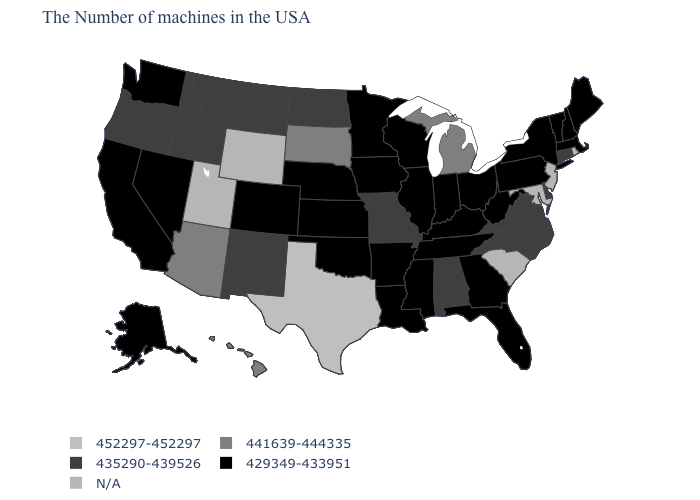What is the value of Georgia?
Concise answer only. 429349-433951. Which states have the highest value in the USA?
Short answer required. Texas. Which states have the lowest value in the USA?
Give a very brief answer. Maine, Massachusetts, New Hampshire, Vermont, New York, Pennsylvania, West Virginia, Ohio, Florida, Georgia, Kentucky, Indiana, Tennessee, Wisconsin, Illinois, Mississippi, Louisiana, Arkansas, Minnesota, Iowa, Kansas, Nebraska, Oklahoma, Colorado, Nevada, California, Washington, Alaska. Which states have the lowest value in the MidWest?
Give a very brief answer. Ohio, Indiana, Wisconsin, Illinois, Minnesota, Iowa, Kansas, Nebraska. What is the value of Arizona?
Quick response, please. 441639-444335. What is the lowest value in the USA?
Keep it brief. 429349-433951. Name the states that have a value in the range 441639-444335?
Write a very short answer. Michigan, South Dakota, Arizona, Hawaii. Is the legend a continuous bar?
Concise answer only. No. Name the states that have a value in the range 429349-433951?
Concise answer only. Maine, Massachusetts, New Hampshire, Vermont, New York, Pennsylvania, West Virginia, Ohio, Florida, Georgia, Kentucky, Indiana, Tennessee, Wisconsin, Illinois, Mississippi, Louisiana, Arkansas, Minnesota, Iowa, Kansas, Nebraska, Oklahoma, Colorado, Nevada, California, Washington, Alaska. Among the states that border Oregon , does Nevada have the highest value?
Write a very short answer. No. Name the states that have a value in the range 429349-433951?
Write a very short answer. Maine, Massachusetts, New Hampshire, Vermont, New York, Pennsylvania, West Virginia, Ohio, Florida, Georgia, Kentucky, Indiana, Tennessee, Wisconsin, Illinois, Mississippi, Louisiana, Arkansas, Minnesota, Iowa, Kansas, Nebraska, Oklahoma, Colorado, Nevada, California, Washington, Alaska. What is the value of Oregon?
Write a very short answer. 435290-439526. What is the value of West Virginia?
Quick response, please. 429349-433951. 